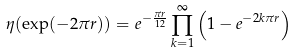<formula> <loc_0><loc_0><loc_500><loc_500>\eta ( \exp ( - 2 \pi r ) ) = e ^ { - \frac { \pi r } { 1 2 } } \prod _ { k = 1 } ^ { \infty } \left ( 1 - e ^ { - 2 k \pi r } \right )</formula> 